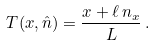<formula> <loc_0><loc_0><loc_500><loc_500>T ( x , { \hat { n } } ) = \frac { x + \ell \, n _ { x } } { L } \, .</formula> 